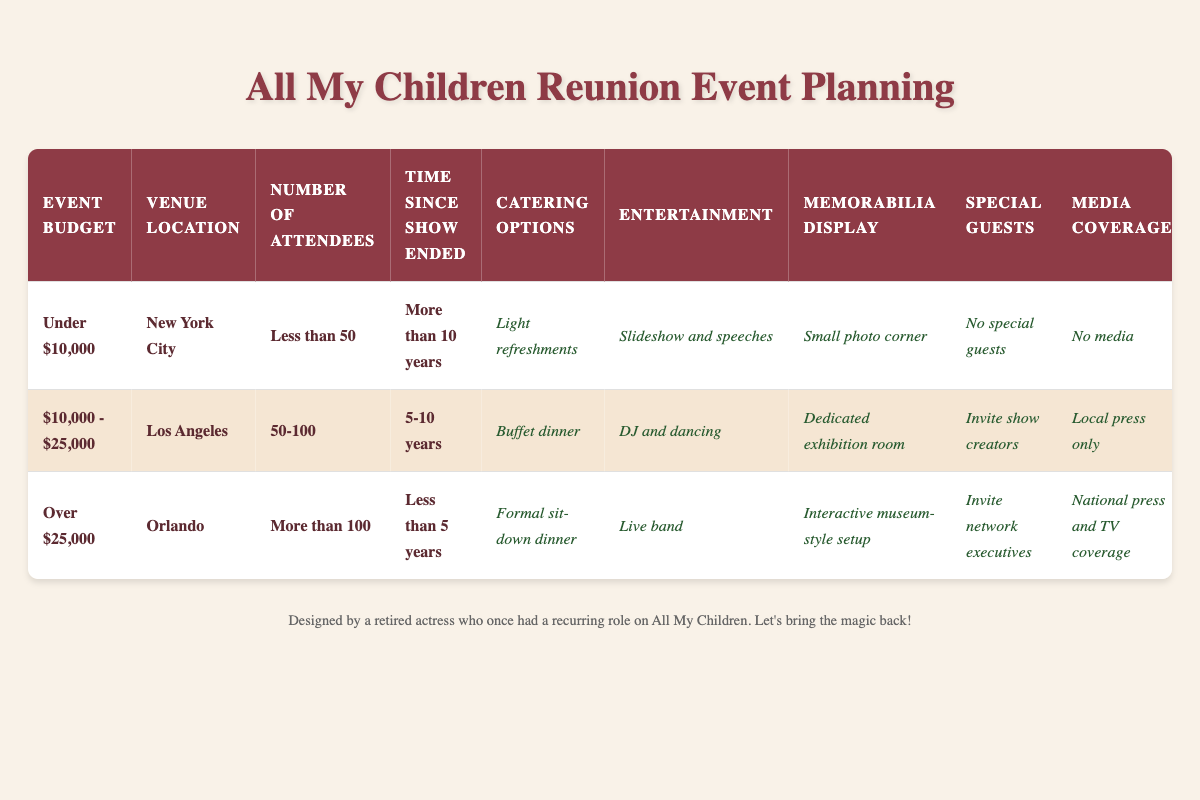What are the catering options for an event with a budget under $10,000? According to the table, for an event budget of under $10,000, the catering option selected is "Light refreshments."
Answer: Light refreshments What is the entertainment choice for an event held in Los Angeles with 50-100 attendees? The table specifies that for events in Los Angeles with 50-100 attendees, the entertainment option is "DJ and dancing."
Answer: DJ and dancing True or False: An event in Orlando with more than 100 attendees includes a dedicated exhibition room as the memorabilia display. In the table, it shows that for an event in Orlando with more than 100 attendees, the memorabilia display is an "Interactive museum-style setup," not a dedicated exhibition room. Thus, the statement is false.
Answer: False How is the media coverage different between events with a budget of over $25,000 and those with a budget of under $10,000? The table outlines that events with a budget of over $25,000 have "National press and TV coverage," whereas events under $10,000 have "No media." This indicates a difference in media presence based on budget category.
Answer: Different media coverage based on budget What are the conditions for hosting a reunion with no special guests? According to the table, the conditions for an event to have "No special guests" is when the event budget is under $10,000, held in New York City, with fewer than 50 attendees, and more than 10 years since the show ended.
Answer: Under $10,000; New York City; Less than 50 attendees; More than 10 years What is the average number of attendees across all listed event types? The table lists three types of attendee counts: Less than 50, 50-100, and More than 100. Assuming values for calculation, let’s say 25 for under 50, 75 for 50-100, and 150 for over 100. Therefore, adding these gives 25 + 75 + 150 = 250. Dividing by 3 types gives an average of 250/3 = approximately 83.33 attendees.
Answer: Approximately 83.33 attendees 